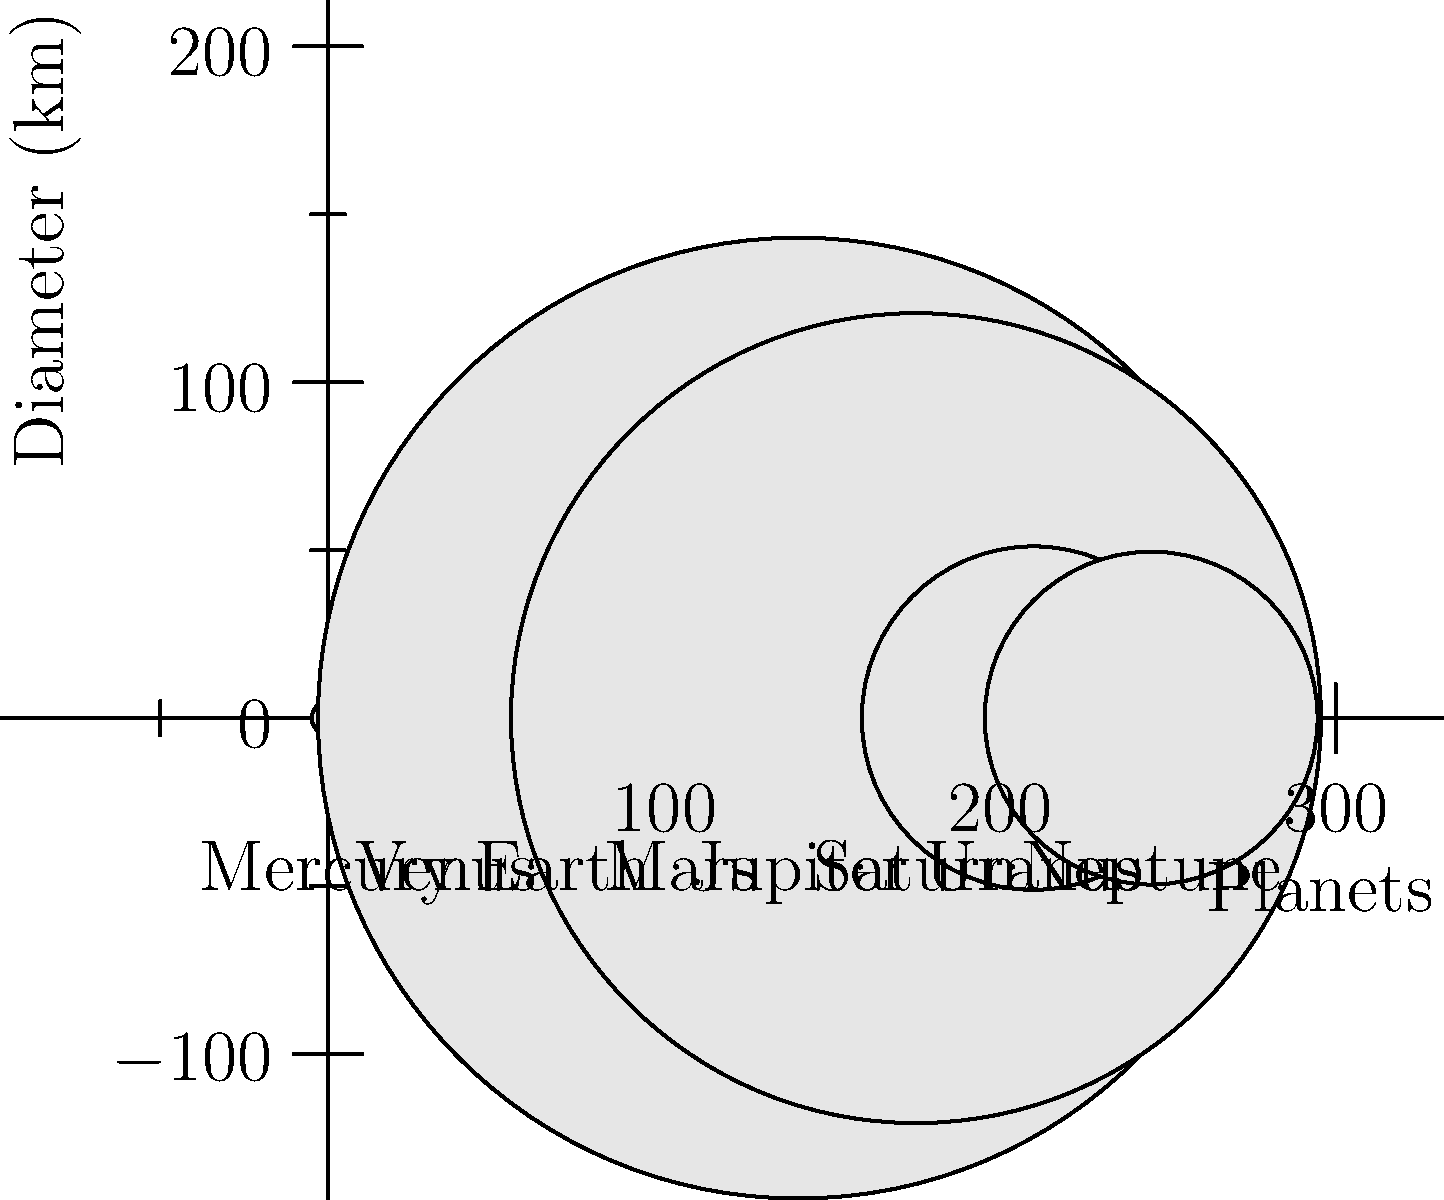In our epic space adventure game, we've just encountered a mysterious alien who challenges us to identify the largest planet in our solar system. Based on the diagram showing the relative sizes of planets, which planet should we choose to impress the alien and advance to the next level? Let's approach this like we're analyzing game stats:

1. The diagram shows the relative sizes of the eight planets in our solar system.
2. Each planet is represented by a circle, with the diameter proportional to the planet's actual size.
3. The planets are arranged in order from left to right: Mercury, Venus, Earth, Mars, Jupiter, Saturn, Uranus, and Neptune.
4. We can clearly see that one planet stands out as significantly larger than the others.
5. This largest circle corresponds to Jupiter.
6. Jupiter is known as a gas giant and is indeed the largest planet in our solar system.
7. Its diameter is approximately 142,984 km, which is more than 11 times the diameter of Earth.

In our game scenario, choosing Jupiter as the largest planet would be the correct move to impress the alien and advance to the next level.
Answer: Jupiter 